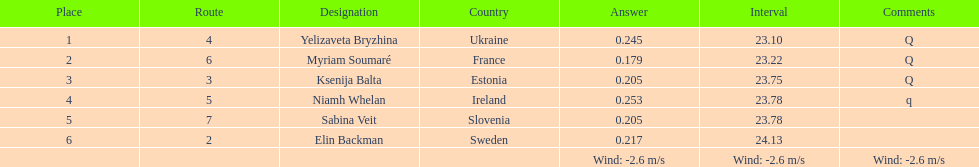How does the time of yelizaveta bryzhina compare to ksenija balta's time? 0.65. Parse the table in full. {'header': ['Place', 'Route', 'Designation', 'Country', 'Answer', 'Interval', 'Comments'], 'rows': [['1', '4', 'Yelizaveta Bryzhina', 'Ukraine', '0.245', '23.10', 'Q'], ['2', '6', 'Myriam Soumaré', 'France', '0.179', '23.22', 'Q'], ['3', '3', 'Ksenija Balta', 'Estonia', '0.205', '23.75', 'Q'], ['4', '5', 'Niamh Whelan', 'Ireland', '0.253', '23.78', 'q'], ['5', '7', 'Sabina Veit', 'Slovenia', '0.205', '23.78', ''], ['6', '2', 'Elin Backman', 'Sweden', '0.217', '24.13', ''], ['', '', '', '', 'Wind: -2.6\xa0m/s', 'Wind: -2.6\xa0m/s', 'Wind: -2.6\xa0m/s']]} 